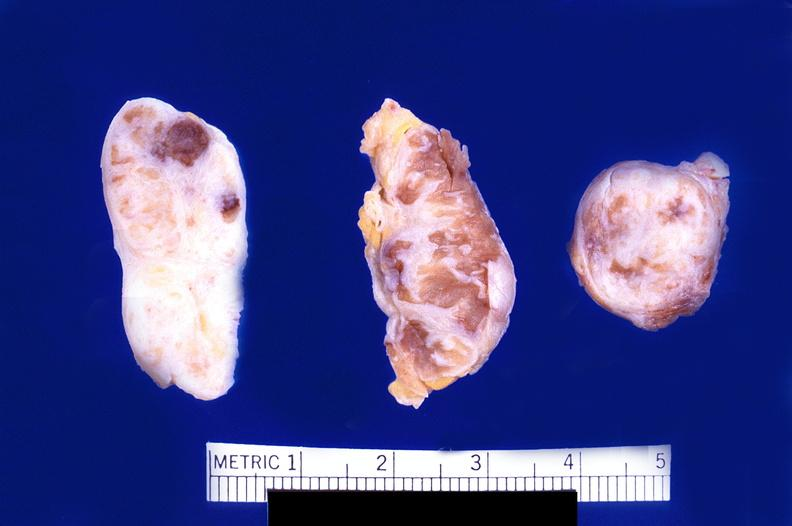does coronary artery show abdominal lymph nodes, nodular sclerosing hodgkins disease?
Answer the question using a single word or phrase. No 